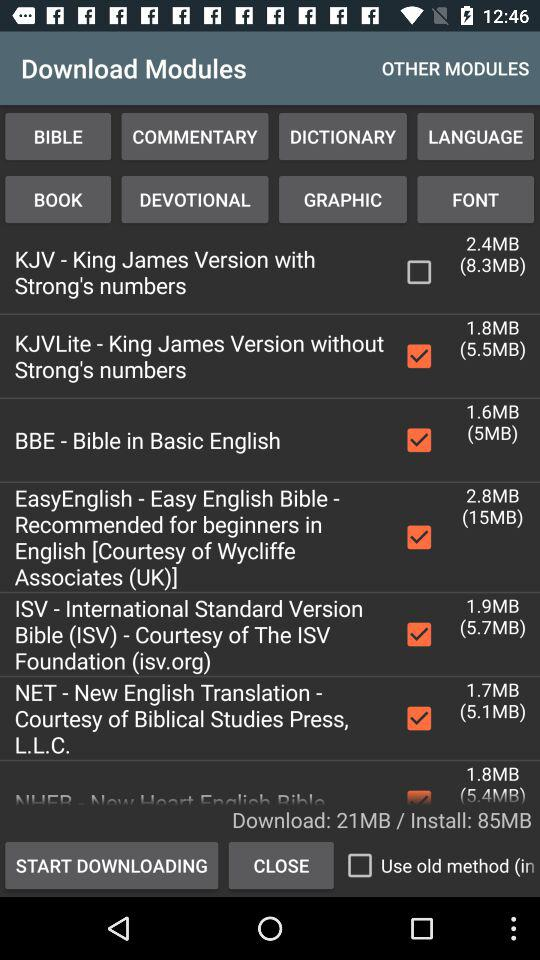What is the status of "NET"? The status is "on". 